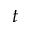Convert formula to latex. <formula><loc_0><loc_0><loc_500><loc_500>t</formula> 